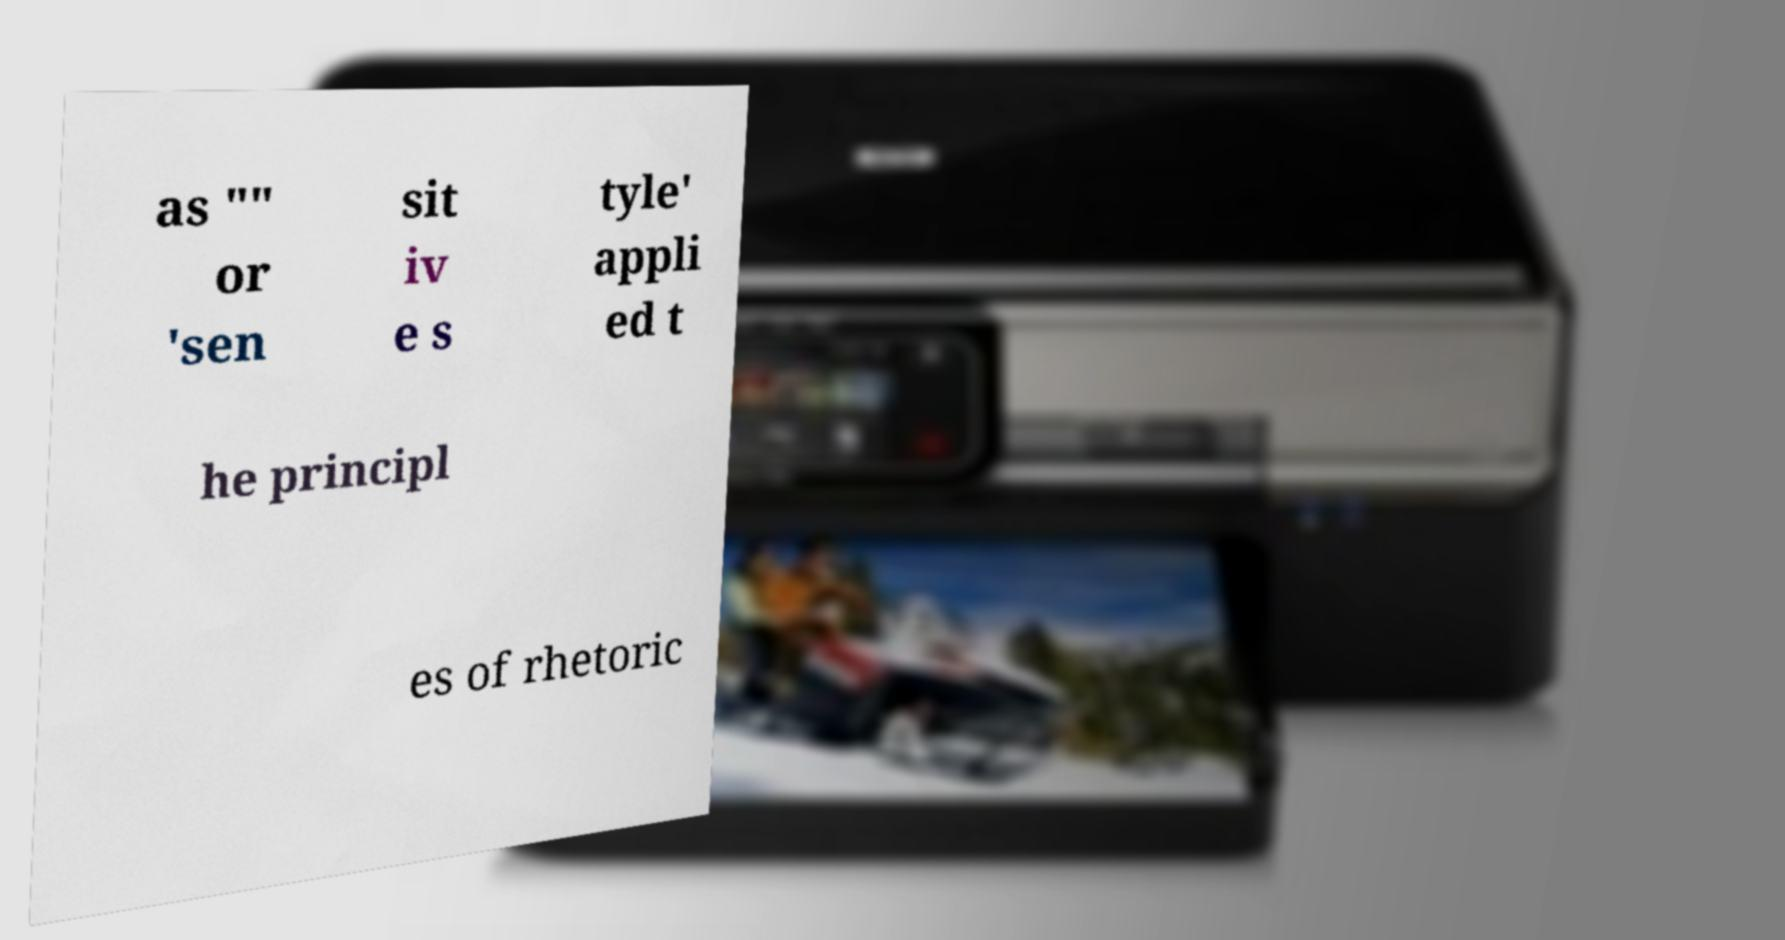There's text embedded in this image that I need extracted. Can you transcribe it verbatim? as "" or 'sen sit iv e s tyle' appli ed t he principl es of rhetoric 